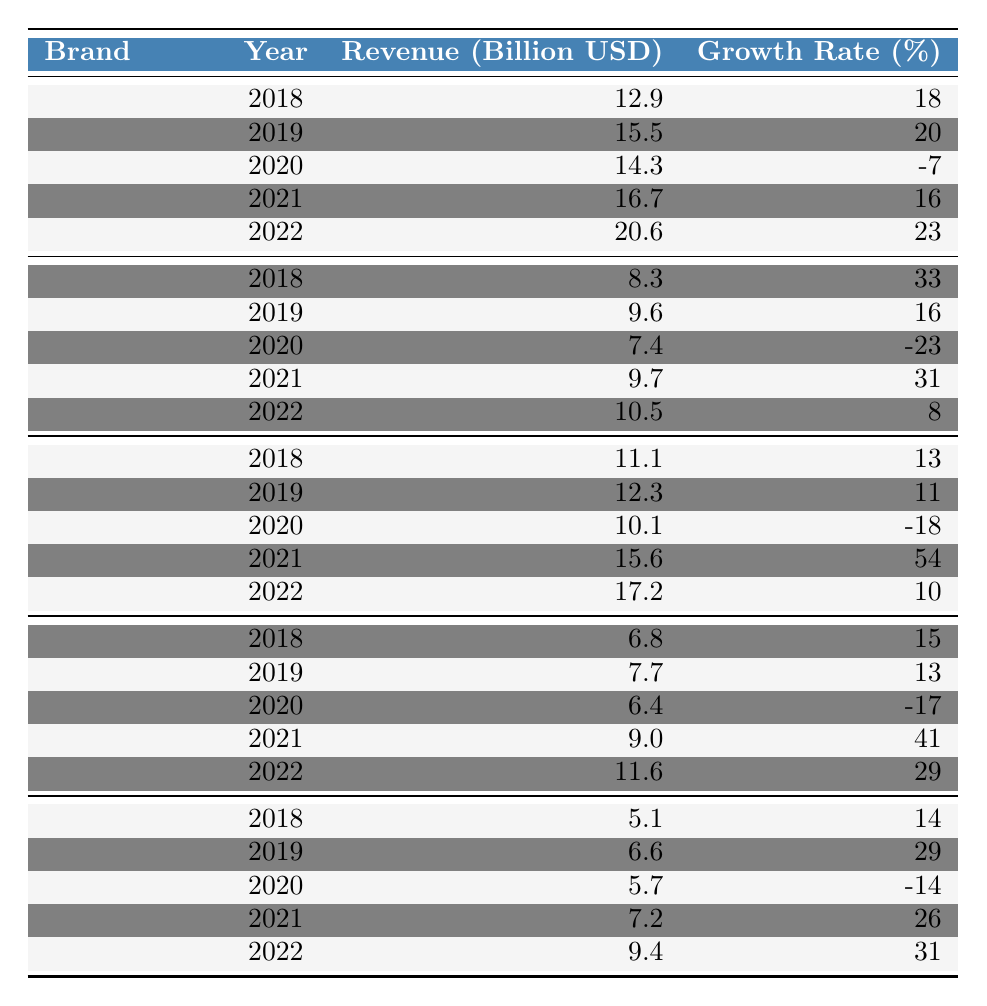What was Louis Vuitton's revenue in 2022? Referring to the table, Louis Vuitton's revenue in 2022 is listed as 20.6 billion USD.
Answer: 20.6 billion USD What is the growth rate of Gucci in 2021? Looking at the table, Gucci's growth rate in 2021 is 31%.
Answer: 31% Which brand had the highest revenue in 2020? According to the table, the brand with the highest revenue in 2020 is Louis Vuitton with 14.3 billion USD.
Answer: Louis Vuitton What was the average growth rate of Chanel over the five years? To find the average growth rate, sum the growth rates: (13 + 11 - 18 + 54 + 10) = 70. Then, divide by the number of years (5), resulting in an average growth rate of 14%.
Answer: 14% Did Hermès experience a negative growth rate in 2020? Yes, in the table, Hermès shows a growth rate of -17% in 2020.
Answer: Yes Which brand had the smallest revenue in 2018? In 2018, the table indicates that Dior had the smallest revenue at 5.1 billion USD.
Answer: Dior How much revenue did Dior make in 2019 compared to 2022? In 2019, Dior's revenue was 6.6 billion USD, and in 2022, it was 9.4 billion USD. The difference is 9.4 - 6.6 = 2.8 billion USD.
Answer: 2.8 billion USD Which brand had the highest growth rate in 2021? By examining the growth rates in 2021, Chanel had the highest growth rate at 54%.
Answer: Chanel What is the total revenue of Hermès over the five years? Summing Hermès revenues: (6.8 + 7.7 + 6.4 + 9.0 + 11.6) = 41.5 billion USD.
Answer: 41.5 billion USD Did Gucci's revenue decrease in 2020? Yes, the table shows that Gucci's revenue in 2020 was 7.4 billion USD, which is a decrease compared to 9.6 billion USD in 2019.
Answer: Yes 